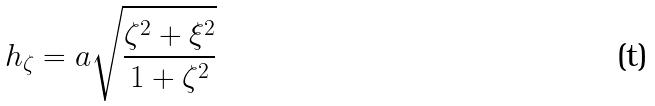Convert formula to latex. <formula><loc_0><loc_0><loc_500><loc_500>h _ { \zeta } = a \sqrt { \frac { \zeta ^ { 2 } + \xi ^ { 2 } } { 1 + \zeta ^ { 2 } } }</formula> 